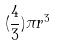<formula> <loc_0><loc_0><loc_500><loc_500>( \frac { 4 } { 3 } ) \pi r ^ { 3 }</formula> 